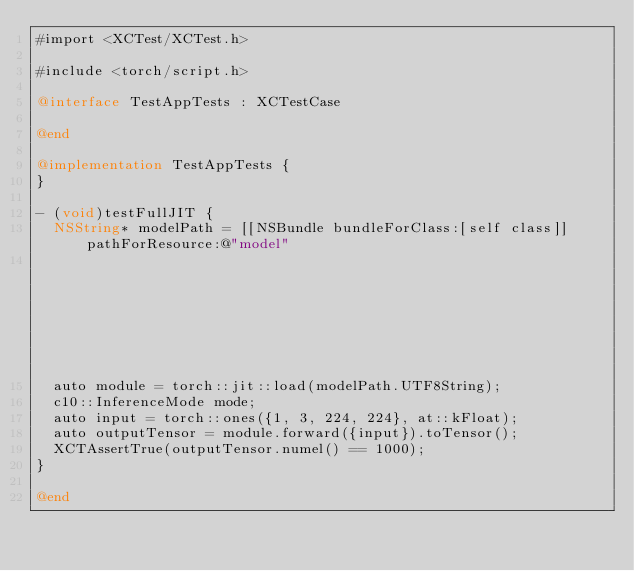<code> <loc_0><loc_0><loc_500><loc_500><_ObjectiveC_>#import <XCTest/XCTest.h>

#include <torch/script.h>

@interface TestAppTests : XCTestCase

@end

@implementation TestAppTests {
}

- (void)testFullJIT {
  NSString* modelPath = [[NSBundle bundleForClass:[self class]] pathForResource:@"model"
                                                                         ofType:@"pt"];
  auto module = torch::jit::load(modelPath.UTF8String);
  c10::InferenceMode mode;
  auto input = torch::ones({1, 3, 224, 224}, at::kFloat);
  auto outputTensor = module.forward({input}).toTensor();
  XCTAssertTrue(outputTensor.numel() == 1000);
}

@end
</code> 